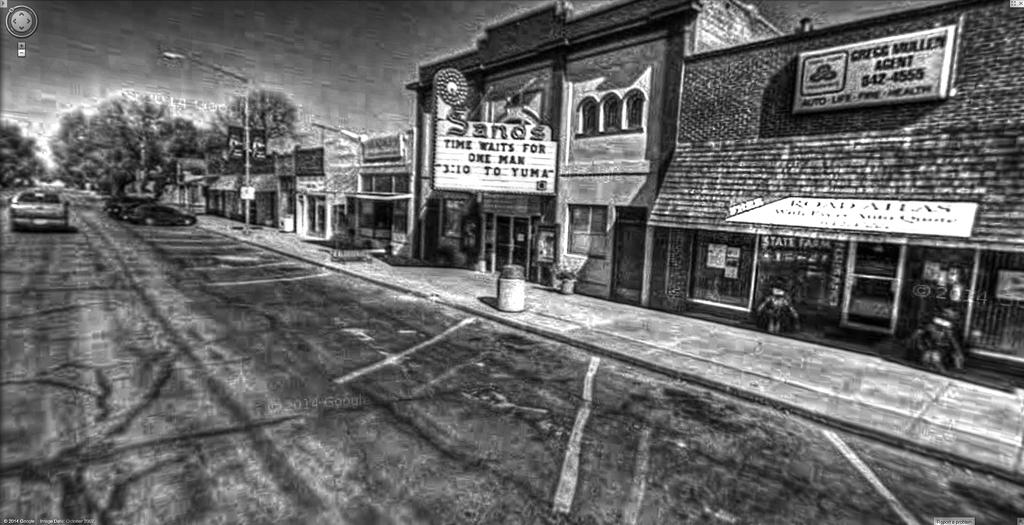<image>
Write a terse but informative summary of the picture. One of the shop signs advertises the name and number of an insurance agent. 